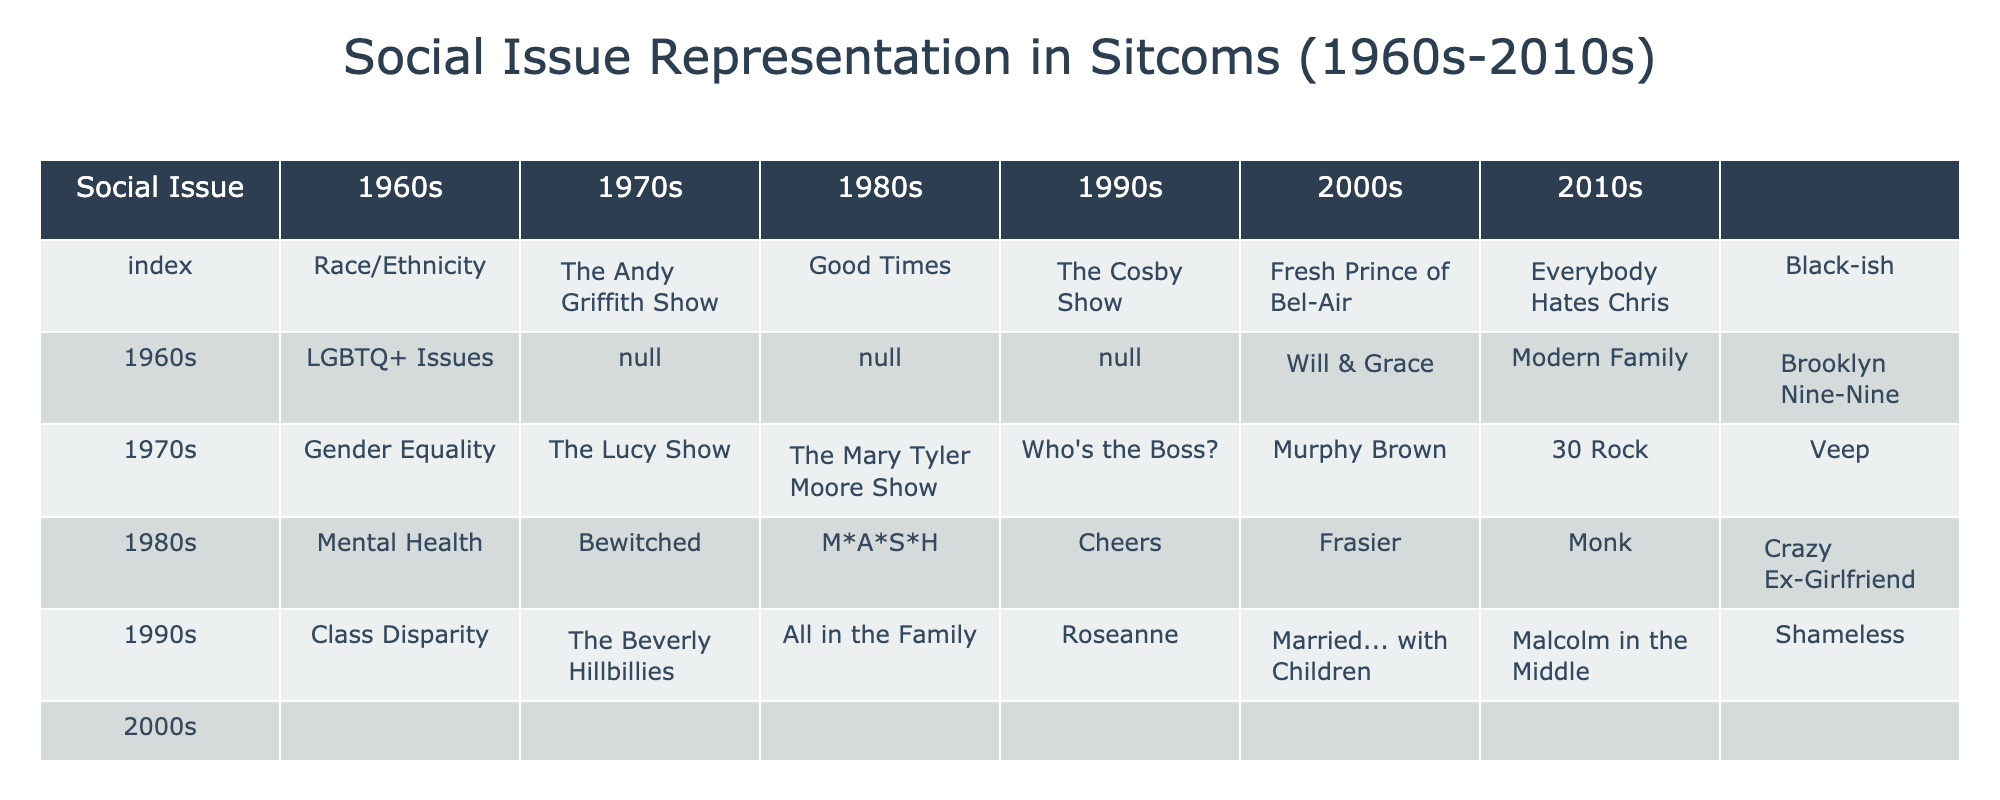What sitcom represented Race/Ethnicity issues in the 1980s? In the 1980s column under Race/Ethnicity, "The Cosby Show" is listed as the sitcom that addressed these issues.
Answer: The Cosby Show Which decade had a sitcom addressing LGBTQ+ issues? The only decade that features a sitcom addressing LGBTQ+ issues is the 1990s, where "Will & Grace" is mentioned.
Answer: 1990s What sitcom addressed Gender Equality in the 2000s? In the 2000s column under Gender Equality, the sitcom "30 Rock" is noted as addressing this issue.
Answer: 30 Rock Is there any sitcom from the 1960s that represented Mental Health? Looking at the 1960s column under Mental Health, there is no sitcom listed, which means there was no representation of this issue during that decade.
Answer: No How many different decades had representation of Class Disparity? The table shows sitcoms addressing Class Disparity in all five decades listed: 1960s, 1970s, 1980s, 1990s, and 2000s. Therefore, we count a total of five decades.
Answer: Five decades What is the difference in representation between Race/Ethnicity in the 1960s and 2010s? In the 1960s, "The Andy Griffith Show" is the representative sitcom, while in the 2010s, "Black-ish" represents Race/Ethnicity. Both decades have distinct shows, but there is no quantitative representation to calculate a difference. However, it implies an evolution in the representation of race issues.
Answer: Distinct shows in both decades, no quantitative difference Which social issue does "Crazy Ex-Girlfriend" address, and in which decade did it air? The sitcom "Crazy Ex-Girlfriend," which aired in the 2010s, is listed under the Mental Health category, indicating it addressed this social issue.
Answer: Mental Health, 2010s Did the representation of LGBTQ+ issues improve from the 1990s to the 2010s? In the 1990s, "Will & Grace" is the only sitcom listed, and in the 2010s, "Brooklyn Nine-Nine" is mentioned without a specific label for LGBTQ+ representation. However, the fact that LGBTQ+ topics became more present in shows over time suggests improvement, even though the table does not explicitly list a second representative show for that issue in the 2010s.
Answer: Yes, improvement suggested despite a lack of explicit listing Which issue saw the earliest sitcom addressing it, according to the table? The earliest sitcom addressing Gender Equality according to the table is "The Lucy Show," which premiered in the 1960s. Thus, it reflects the earliest effort in this social issue representation in sitcoms.
Answer: The Lucy Show, Gender Equality 1960s In terms of Class Disparity, which decade had the sitcom "All in the Family"? "All in the Family" is listed under Class Disparity in the 1970s column, which indicates that this sitcom represented issues related to Class Disparity during that decade.
Answer: 1970s 